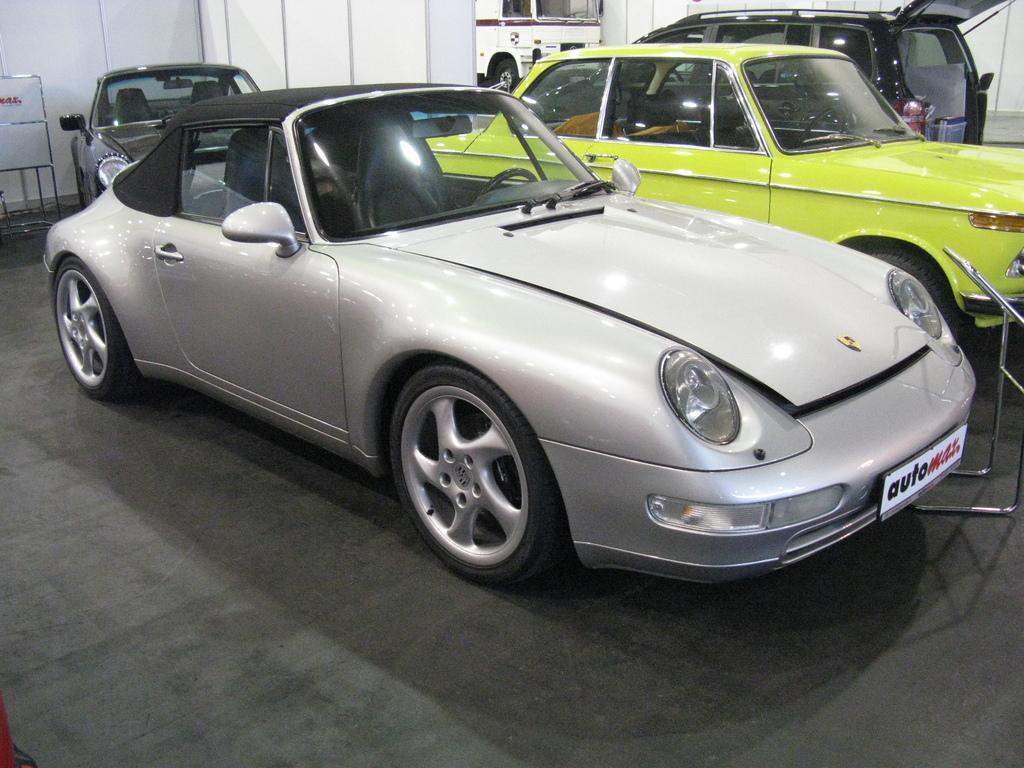How would you summarize this image in a sentence or two? In this image there are vehicles, there is an object towards the right of the image, there is a board towards the left of the image, there is text on the board, there is the wall towards the top of the image, there is an object towards the bottom of the image. 